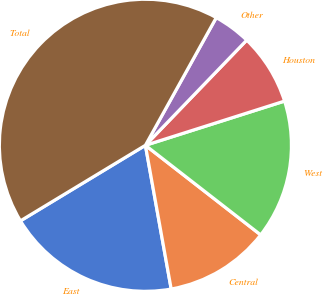Convert chart. <chart><loc_0><loc_0><loc_500><loc_500><pie_chart><fcel>East<fcel>Central<fcel>West<fcel>Houston<fcel>Other<fcel>Total<nl><fcel>19.17%<fcel>11.66%<fcel>15.41%<fcel>7.9%<fcel>4.14%<fcel>41.72%<nl></chart> 